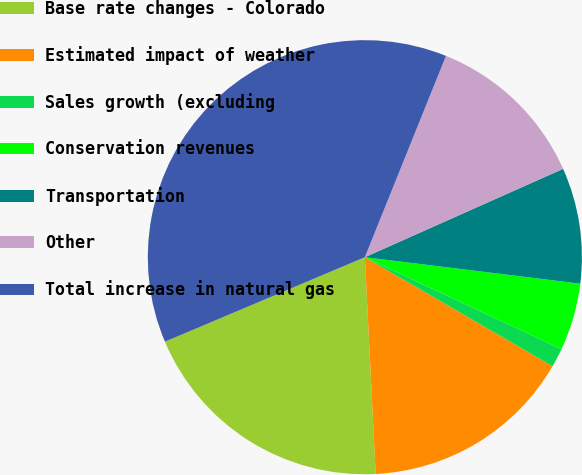<chart> <loc_0><loc_0><loc_500><loc_500><pie_chart><fcel>Base rate changes - Colorado<fcel>Estimated impact of weather<fcel>Sales growth (excluding<fcel>Conservation revenues<fcel>Transportation<fcel>Other<fcel>Total increase in natural gas<nl><fcel>19.43%<fcel>15.83%<fcel>1.41%<fcel>5.02%<fcel>8.62%<fcel>12.23%<fcel>37.46%<nl></chart> 